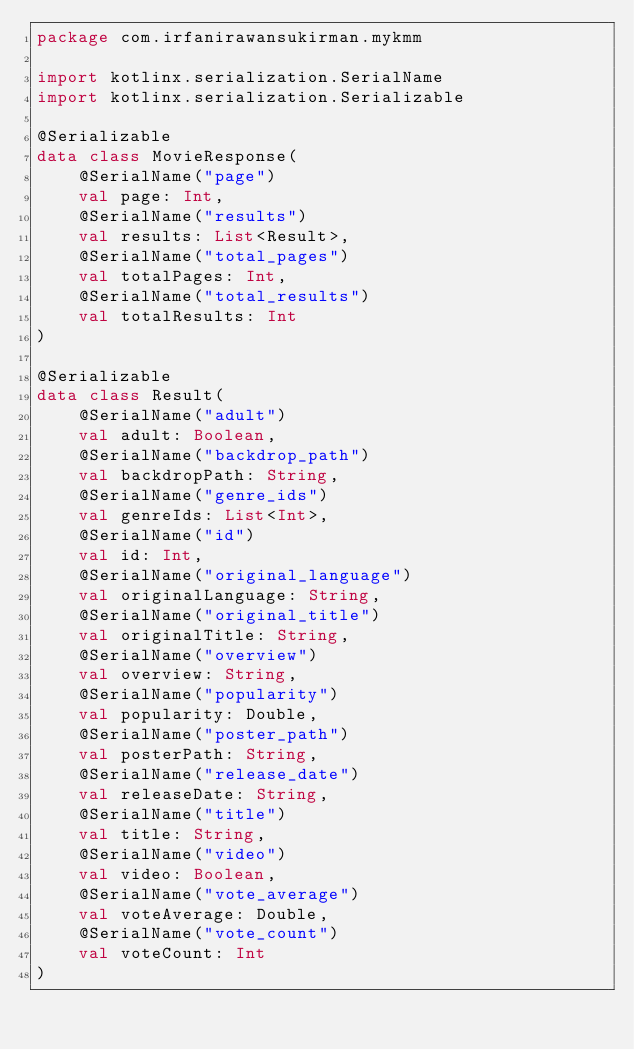Convert code to text. <code><loc_0><loc_0><loc_500><loc_500><_Kotlin_>package com.irfanirawansukirman.mykmm

import kotlinx.serialization.SerialName
import kotlinx.serialization.Serializable

@Serializable
data class MovieResponse(
    @SerialName("page")
    val page: Int,
    @SerialName("results")
    val results: List<Result>,
    @SerialName("total_pages")
    val totalPages: Int,
    @SerialName("total_results")
    val totalResults: Int
)

@Serializable
data class Result(
    @SerialName("adult")
    val adult: Boolean,
    @SerialName("backdrop_path")
    val backdropPath: String,
    @SerialName("genre_ids")
    val genreIds: List<Int>,
    @SerialName("id")
    val id: Int,
    @SerialName("original_language")
    val originalLanguage: String,
    @SerialName("original_title")
    val originalTitle: String,
    @SerialName("overview")
    val overview: String,
    @SerialName("popularity")
    val popularity: Double,
    @SerialName("poster_path")
    val posterPath: String,
    @SerialName("release_date")
    val releaseDate: String,
    @SerialName("title")
    val title: String,
    @SerialName("video")
    val video: Boolean,
    @SerialName("vote_average")
    val voteAverage: Double,
    @SerialName("vote_count")
    val voteCount: Int
)</code> 